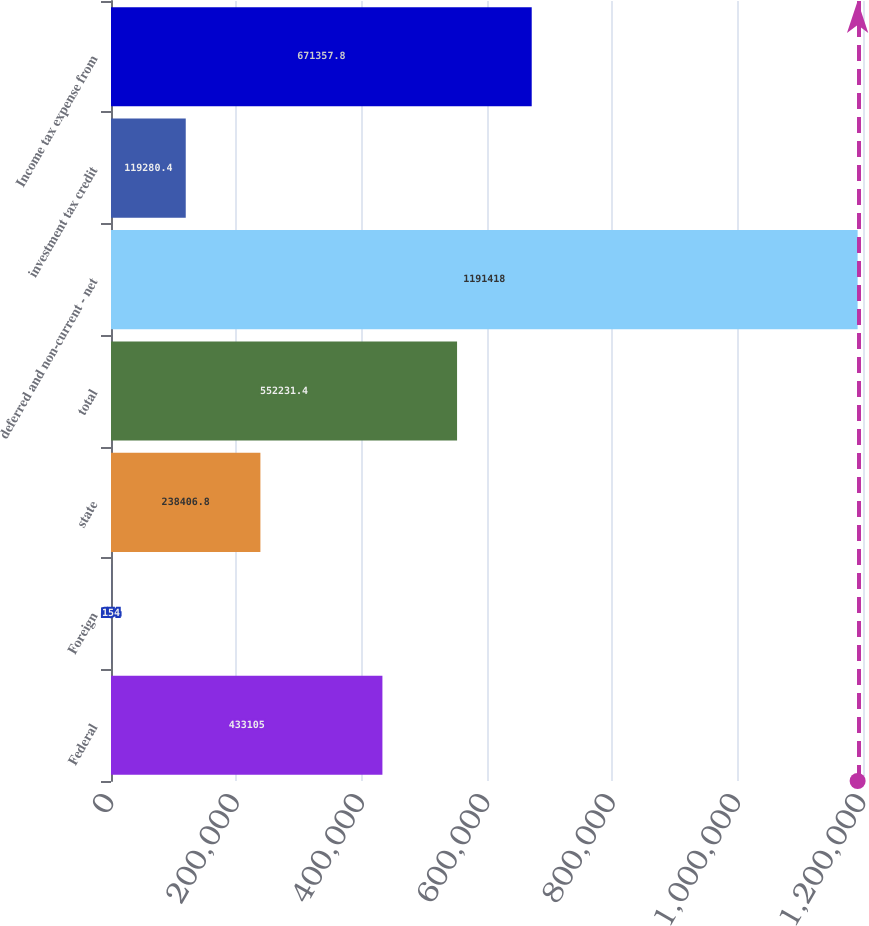Convert chart to OTSL. <chart><loc_0><loc_0><loc_500><loc_500><bar_chart><fcel>Federal<fcel>Foreign<fcel>state<fcel>total<fcel>deferred and non-current - net<fcel>investment tax credit<fcel>Income tax expense from<nl><fcel>433105<fcel>154<fcel>238407<fcel>552231<fcel>1.19142e+06<fcel>119280<fcel>671358<nl></chart> 